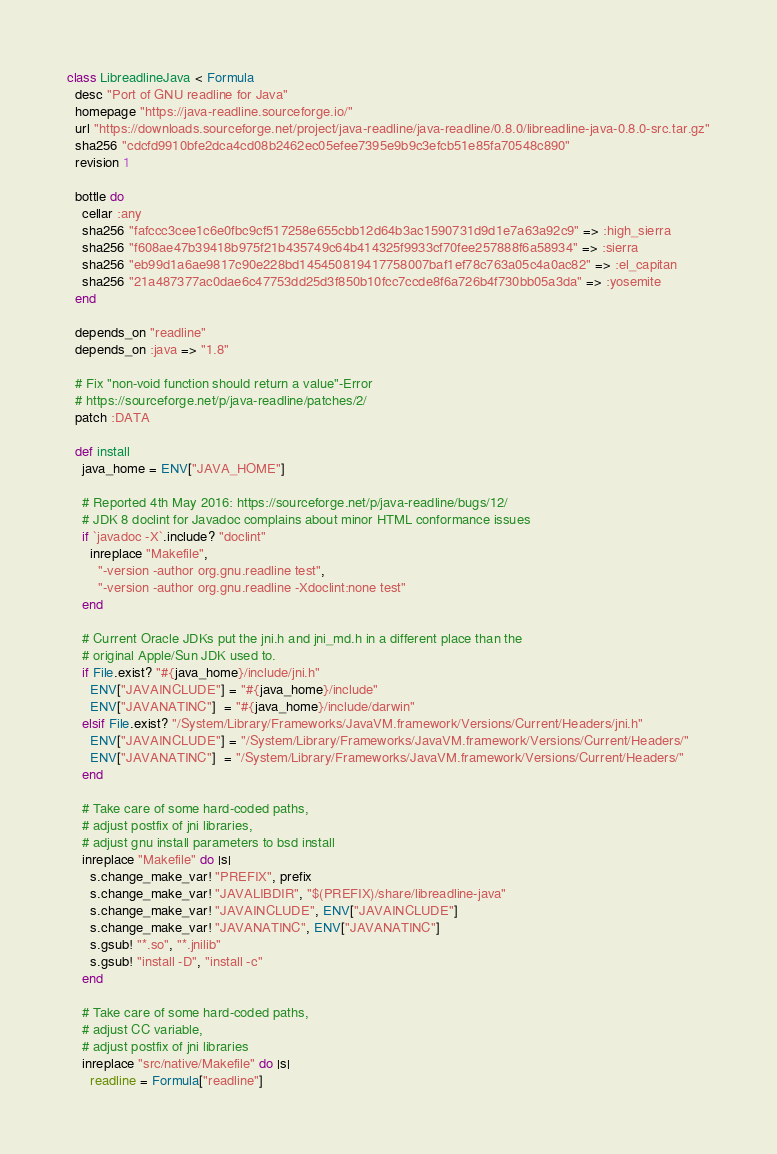Convert code to text. <code><loc_0><loc_0><loc_500><loc_500><_Ruby_>class LibreadlineJava < Formula
  desc "Port of GNU readline for Java"
  homepage "https://java-readline.sourceforge.io/"
  url "https://downloads.sourceforge.net/project/java-readline/java-readline/0.8.0/libreadline-java-0.8.0-src.tar.gz"
  sha256 "cdcfd9910bfe2dca4cd08b2462ec05efee7395e9b9c3efcb51e85fa70548c890"
  revision 1

  bottle do
    cellar :any
    sha256 "fafccc3cee1c6e0fbc9cf517258e655cbb12d64b3ac1590731d9d1e7a63a92c9" => :high_sierra
    sha256 "f608ae47b39418b975f21b435749c64b414325f9933cf70fee257888f6a58934" => :sierra
    sha256 "eb99d1a6ae9817c90e228bd145450819417758007baf1ef78c763a05c4a0ac82" => :el_capitan
    sha256 "21a487377ac0dae6c47753dd25d3f850b10fcc7ccde8f6a726b4f730bb05a3da" => :yosemite
  end

  depends_on "readline"
  depends_on :java => "1.8"

  # Fix "non-void function should return a value"-Error
  # https://sourceforge.net/p/java-readline/patches/2/
  patch :DATA

  def install
    java_home = ENV["JAVA_HOME"]

    # Reported 4th May 2016: https://sourceforge.net/p/java-readline/bugs/12/
    # JDK 8 doclint for Javadoc complains about minor HTML conformance issues
    if `javadoc -X`.include? "doclint"
      inreplace "Makefile",
        "-version -author org.gnu.readline test",
        "-version -author org.gnu.readline -Xdoclint:none test"
    end

    # Current Oracle JDKs put the jni.h and jni_md.h in a different place than the
    # original Apple/Sun JDK used to.
    if File.exist? "#{java_home}/include/jni.h"
      ENV["JAVAINCLUDE"] = "#{java_home}/include"
      ENV["JAVANATINC"]  = "#{java_home}/include/darwin"
    elsif File.exist? "/System/Library/Frameworks/JavaVM.framework/Versions/Current/Headers/jni.h"
      ENV["JAVAINCLUDE"] = "/System/Library/Frameworks/JavaVM.framework/Versions/Current/Headers/"
      ENV["JAVANATINC"]  = "/System/Library/Frameworks/JavaVM.framework/Versions/Current/Headers/"
    end

    # Take care of some hard-coded paths,
    # adjust postfix of jni libraries,
    # adjust gnu install parameters to bsd install
    inreplace "Makefile" do |s|
      s.change_make_var! "PREFIX", prefix
      s.change_make_var! "JAVALIBDIR", "$(PREFIX)/share/libreadline-java"
      s.change_make_var! "JAVAINCLUDE", ENV["JAVAINCLUDE"]
      s.change_make_var! "JAVANATINC", ENV["JAVANATINC"]
      s.gsub! "*.so", "*.jnilib"
      s.gsub! "install -D", "install -c"
    end

    # Take care of some hard-coded paths,
    # adjust CC variable,
    # adjust postfix of jni libraries
    inreplace "src/native/Makefile" do |s|
      readline = Formula["readline"]</code> 